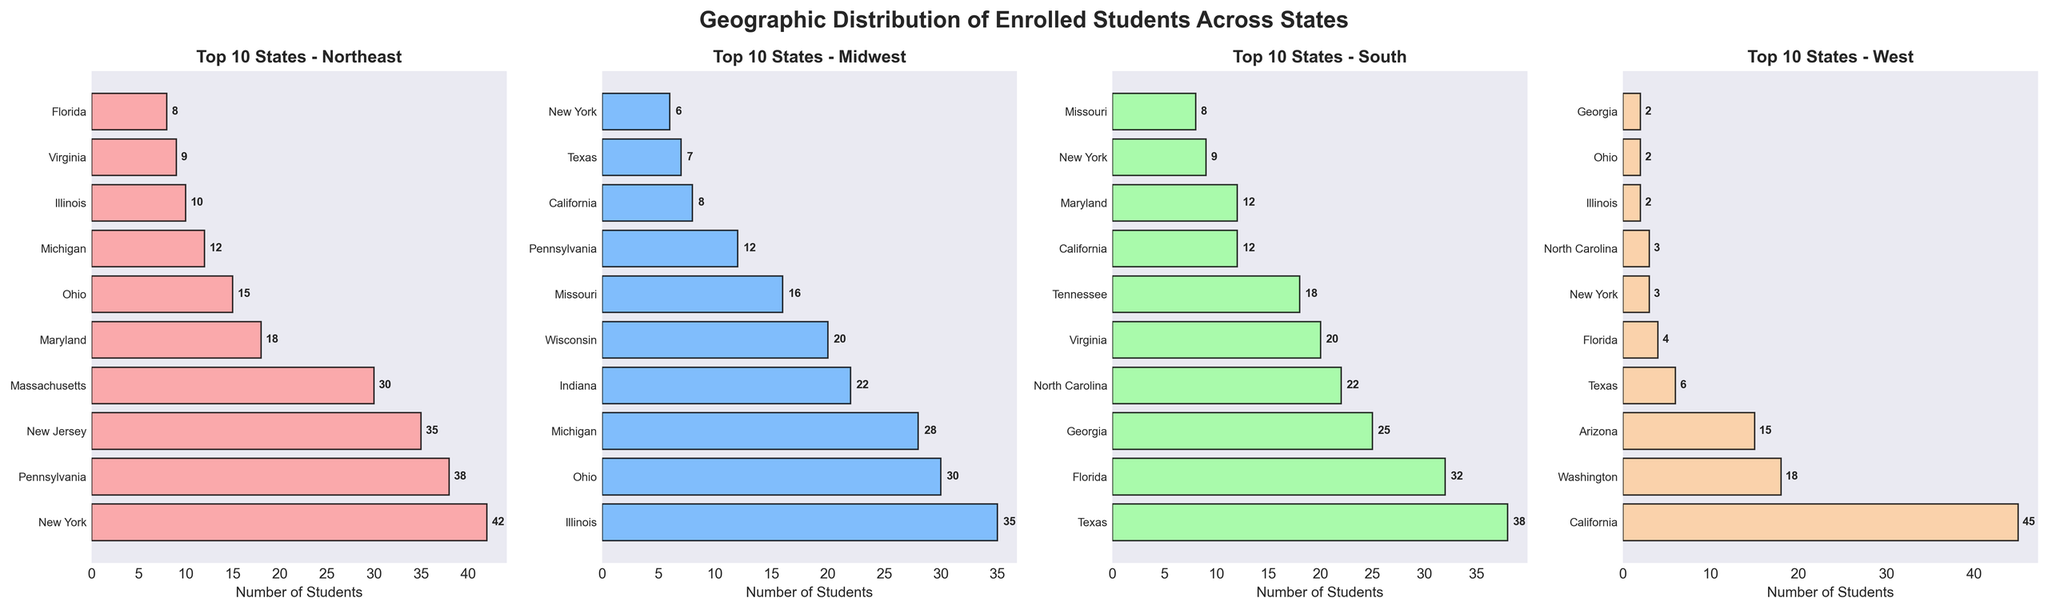What state has the highest number of students from the West region? The bar chart for the West region shows that California has the tallest bar and the highest number.
Answer: California Which two states have the closest number of students in the Midwest region? By comparing the lengths of the bars in the Midwest region, Ohio and Michigan have 30 and 28 students respectively, which are the closest.
Answer: Ohio and Michigan What is the total number of students from New York across all regions? Sum the number of students from New York in each region: 42 (Northeast) + 6 (Midwest) + 9 (South) + 3 (West). The total is 60.
Answer: 60 How many more students are there from the Northeast region of New Jersey compared to Pennsylvania? The bar chart for the Northeast region shows New Jersey with 35 students and Pennsylvania with 38 students. Subtract Pennsylvania’s number from New Jersey’s: 35 - 38 = -3.
Answer: -3 Which state appears in the top 10 for the most regions? By inspecting which states appear multiple times across the four bar charts, New York appears in the top 10 for all regions except West making it the state with the most appearances.
Answer: New York What is the average number of students from Illinois across all the regions? Calculate the mean by adding the number of students in each region and dividing by 4: (10 + 35 + 7 + 2)/4 = 13.5.
Answer: 13.5 Compare the number of students from Florida and Georgia in the South region. Which state has more, and by how much? Florida has 32 students, and Georgia has 25 in the South region. 32 - 25 = 7, so Florida has 7 more students.
Answer: Florida, 7 What is the sum of students from the top 3 states in the West region? Identify the top 3 states from the West region chart: California (45), Washington (18), and Arizona (15). Sum them up: 45 + 18 + 15 = 78.
Answer: 78 Identify the state with the least number of students in the West region and provide the count. The shortest bar in the West region belongs to Pennsylvania, which has 1 student.
Answer: Pennsylvania, 1 